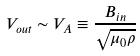<formula> <loc_0><loc_0><loc_500><loc_500>V _ { o u t } \sim V _ { A } \equiv \frac { B _ { i n } } { \sqrt { \mu _ { 0 } \rho } }</formula> 